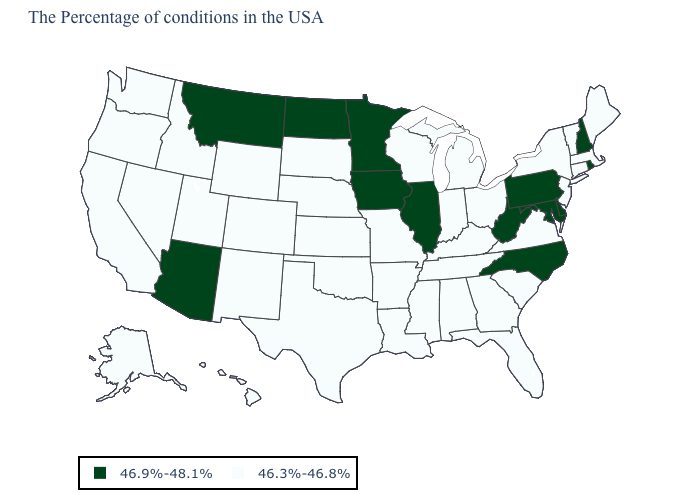What is the value of Washington?
Short answer required. 46.3%-46.8%. Among the states that border Montana , does South Dakota have the highest value?
Quick response, please. No. What is the value of Massachusetts?
Answer briefly. 46.3%-46.8%. Which states have the highest value in the USA?
Be succinct. Rhode Island, New Hampshire, Delaware, Maryland, Pennsylvania, North Carolina, West Virginia, Illinois, Minnesota, Iowa, North Dakota, Montana, Arizona. Which states hav the highest value in the Northeast?
Concise answer only. Rhode Island, New Hampshire, Pennsylvania. Does Maryland have the lowest value in the USA?
Write a very short answer. No. Does Illinois have the highest value in the USA?
Quick response, please. Yes. Does California have a lower value than North Dakota?
Answer briefly. Yes. Which states have the highest value in the USA?
Give a very brief answer. Rhode Island, New Hampshire, Delaware, Maryland, Pennsylvania, North Carolina, West Virginia, Illinois, Minnesota, Iowa, North Dakota, Montana, Arizona. Which states hav the highest value in the Northeast?
Answer briefly. Rhode Island, New Hampshire, Pennsylvania. Among the states that border Montana , does North Dakota have the highest value?
Be succinct. Yes. Does Rhode Island have a higher value than Georgia?
Be succinct. Yes. How many symbols are there in the legend?
Keep it brief. 2. Does Nebraska have the lowest value in the MidWest?
Be succinct. Yes. 